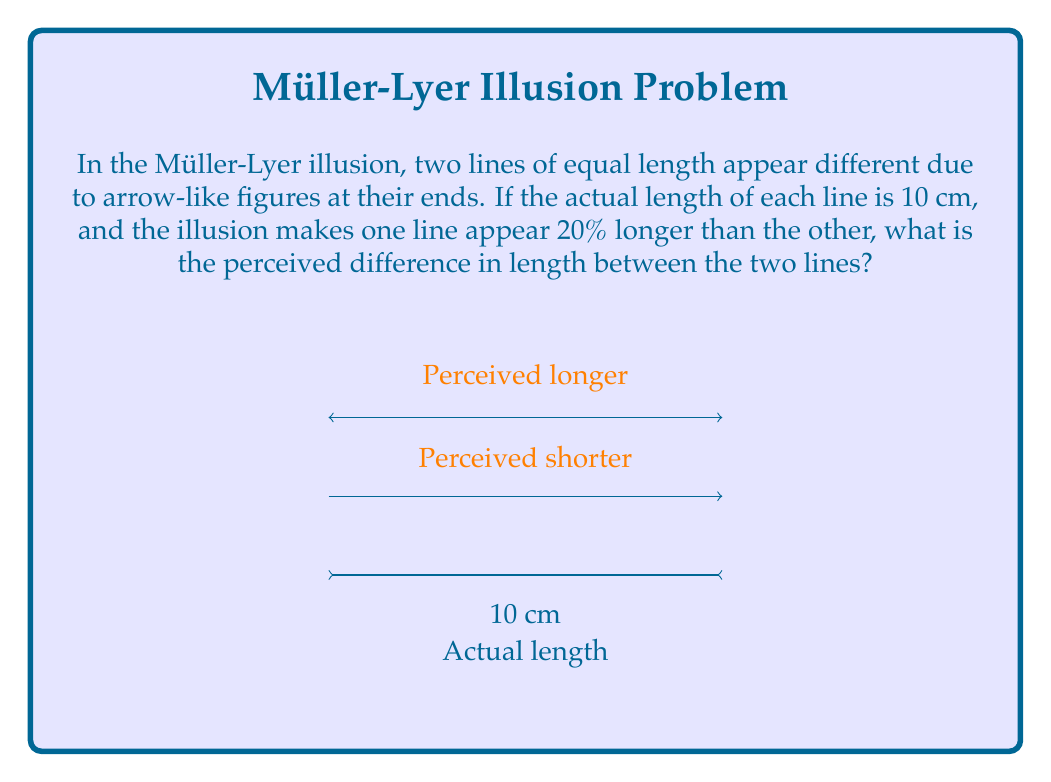Teach me how to tackle this problem. Let's approach this step-by-step:

1) First, we need to understand what the illusion does:
   - Both lines are actually 10 cm long.
   - One line appears 20% longer than the other due to the illusion.

2) Let's define variables:
   - Let $x$ be the perceived length of the shorter line.
   - The longer line is perceived to be 20% longer than $x$.

3) We can express this mathematically:
   $$ \text{Longer perceived length} = x + 20\% \cdot x = 1.2x $$

4) Now, we know that the actual length of both lines is 10 cm. So:
   $$ x + 1.2x = 20 $$

5) Simplify:
   $$ 2.2x = 20 $$

6) Solve for $x$:
   $$ x = \frac{20}{2.2} \approx 9.09 \text{ cm} $$

7) The longer perceived length is:
   $$ 1.2x \approx 1.2 \cdot 9.09 \approx 10.91 \text{ cm} $$

8) The perceived difference is:
   $$ 10.91 - 9.09 = 1.82 \text{ cm} $$

This mathematical analysis shows how a geometric illusion can create a measurable difference in perception, even when the physical lengths are identical.
Answer: 1.82 cm 